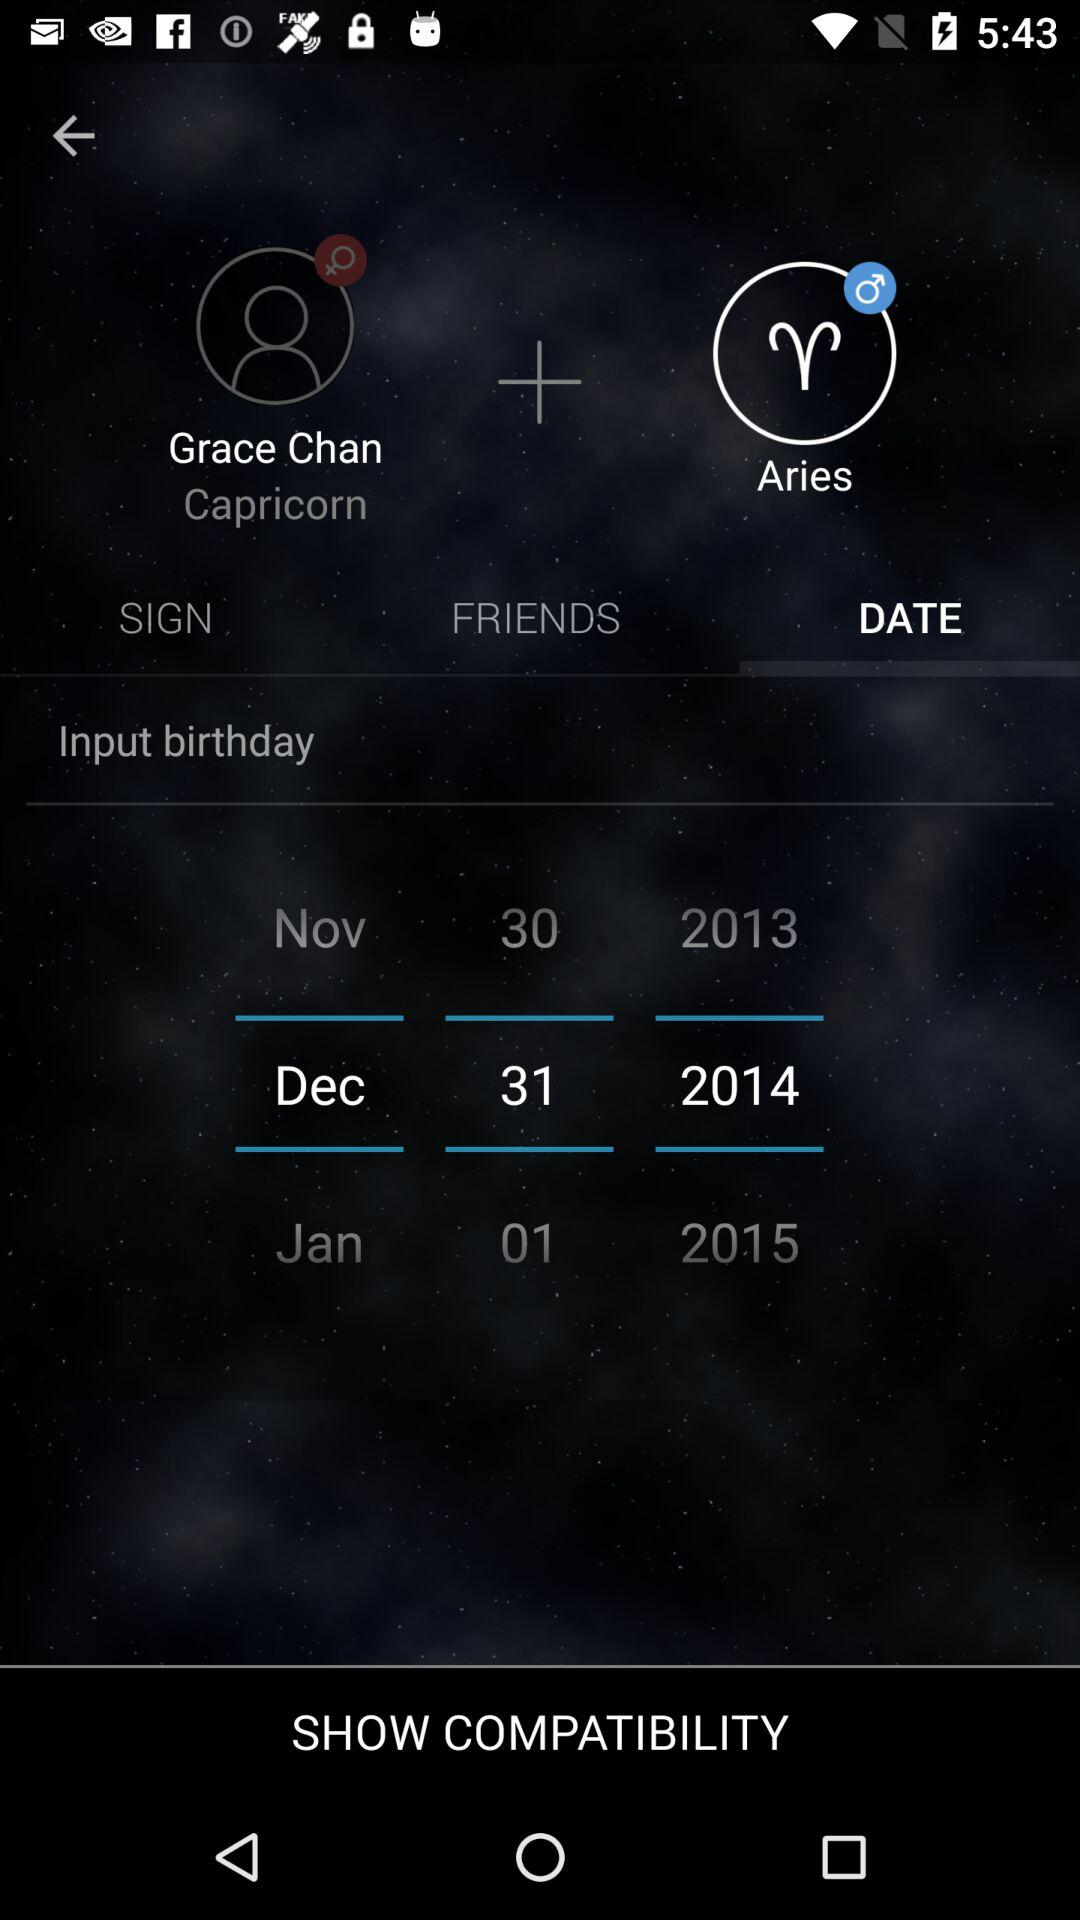What is the selected birthday date? The selected birthday date is December 31, 2014. 